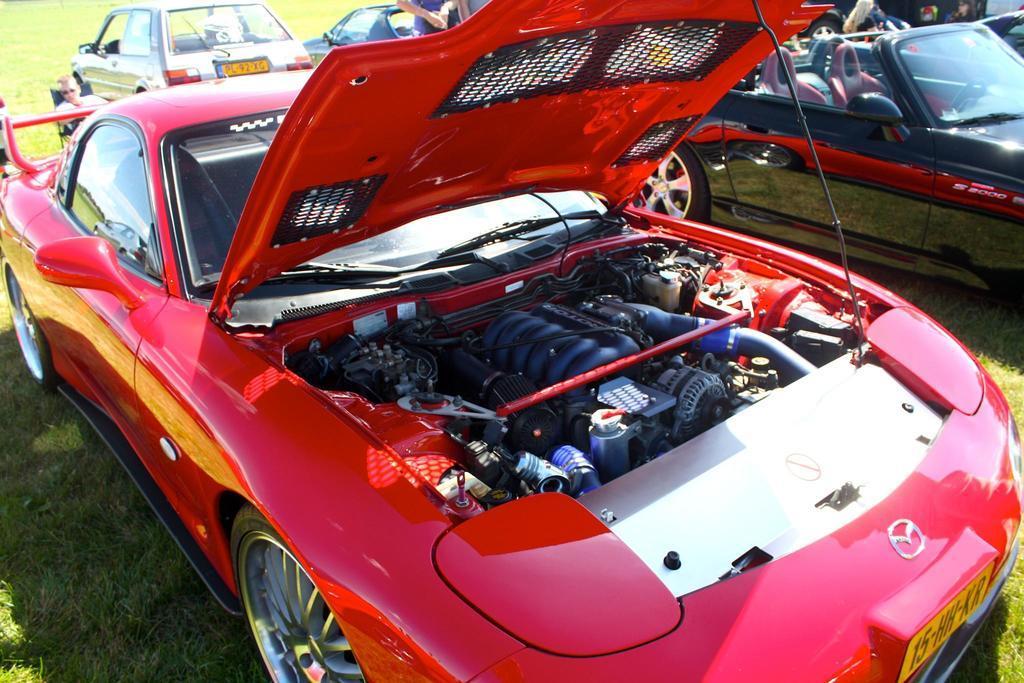In one or two sentences, can you explain what this image depicts? In this image there are cars on the surface of the grass and at the back side there is a person sitting on the chair. 